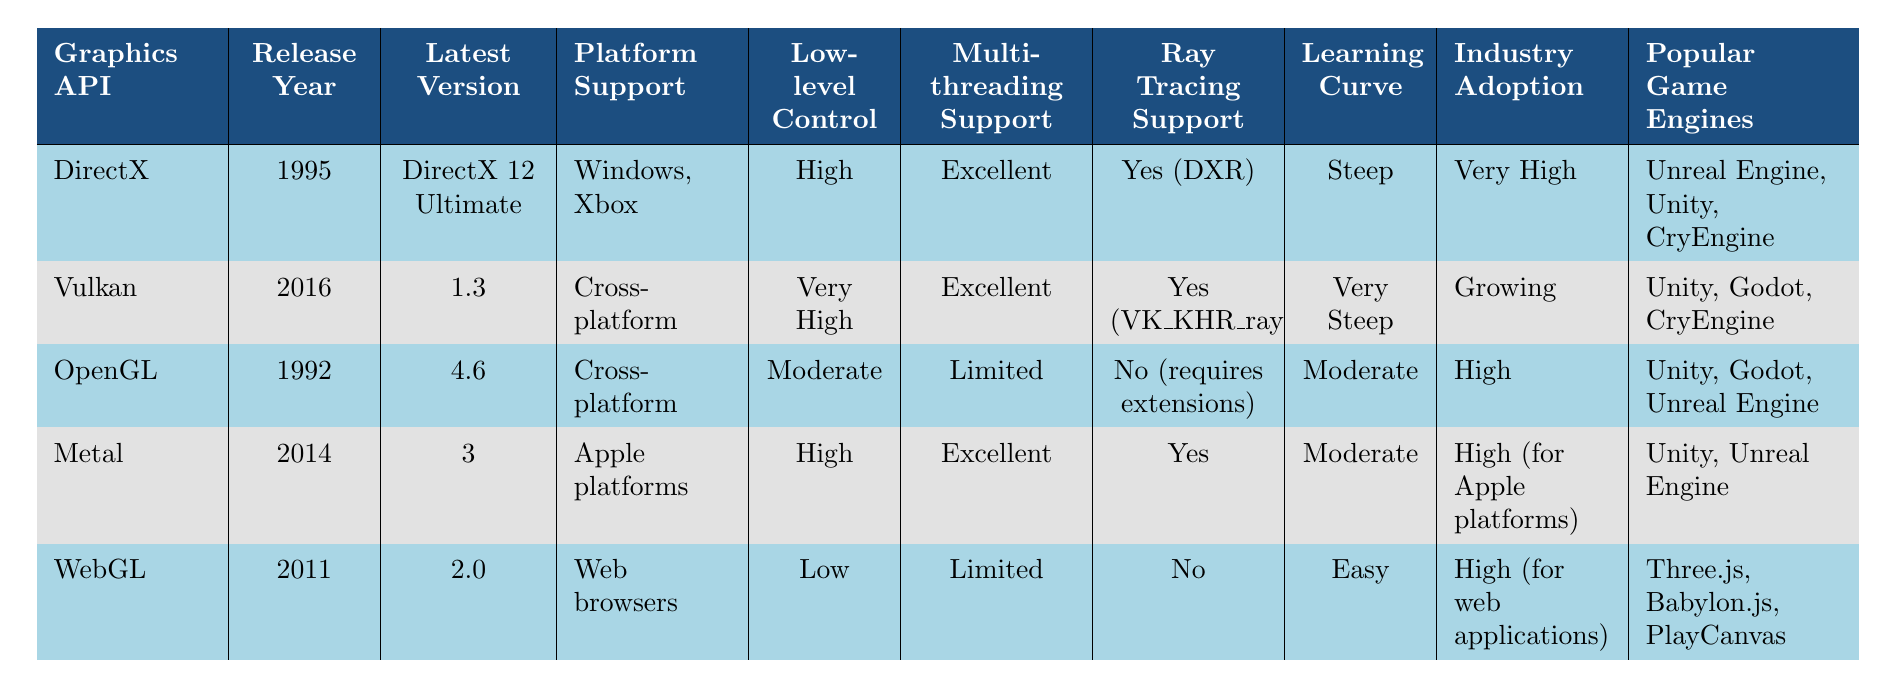What is the latest version of Vulkan? The table indicates that the latest version of Vulkan is 1.3.
Answer: 1.3 Which graphics API has the highest level of low-level control? By comparing the "Low-level Control" column, Vulkan has "Very High" and is higher than DirectX and Metal, which both have "High."
Answer: Vulkan Does OpenGL support ray tracing? According to the "Ray Tracing Support" column, OpenGL does not support ray tracing natively and requires extensions for that.
Answer: No Which graphics APIs support multi-threading excellently? The "Multi-threading Support" column shows that both Vulkan and DirectX have "Excellent" multi-threading support.
Answer: Vulkan, DirectX Which graphics API was released first? Checking the "Release Year" column, OpenGL was released in 1992, making it the earliest among the listed APIs.
Answer: OpenGL How many graphics APIs have "Moderate" learning curves? Referring to the "Learning Curve" column, both OpenGL and Metal have a "Moderate" learning curve, so there are two APIs.
Answer: 2 Is the industry adoption of Vulkan high? In the "Industry Adoption" column, Vulkan is marked as "Growing," which indicates that it is still in the process of achieving high adoption.
Answer: No Which graphics API is exclusively supported on Apple platforms? From the "Platform Support" column, Metal is the only graphics API listed that is only for Apple platforms.
Answer: Metal What is the average release year of all the listed graphics APIs? Summing their release years: (1995 + 2016 + 1992 + 2014 + 2011) = 10028, and dividing by 5 results in an average release year of 2005.6, which we can round to 2006.
Answer: 2006 